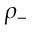Convert formula to latex. <formula><loc_0><loc_0><loc_500><loc_500>\rho _ { - }</formula> 